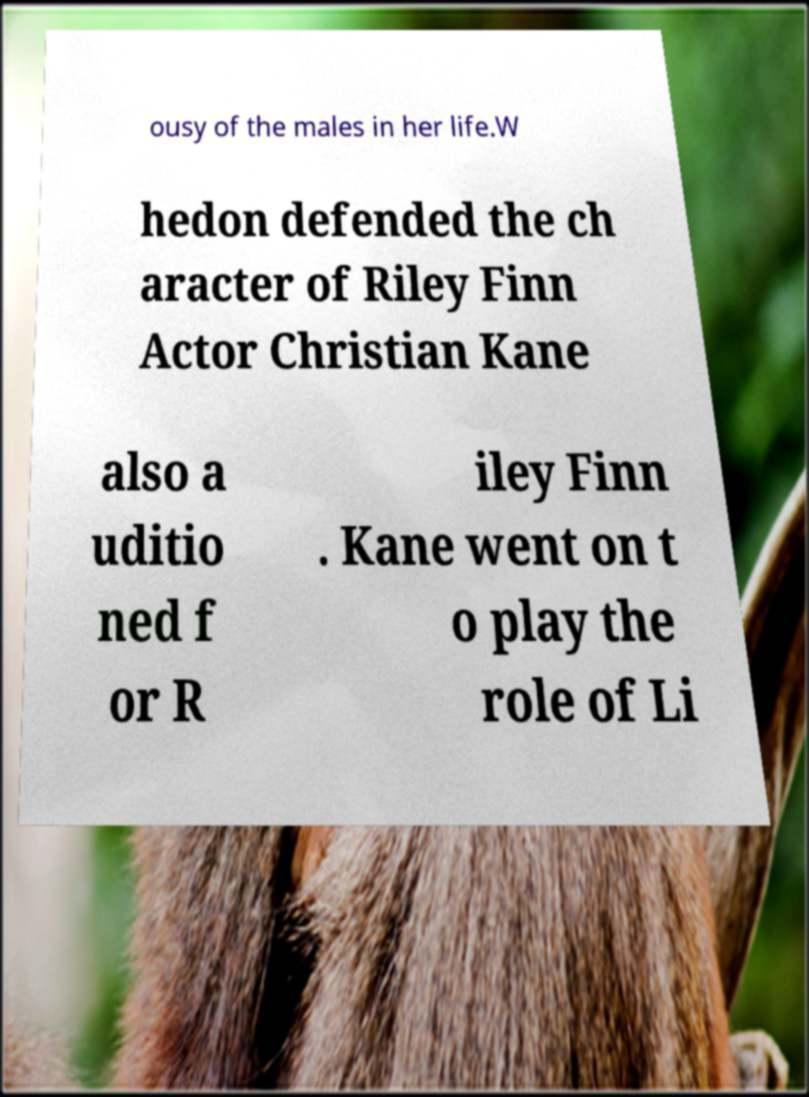Can you read and provide the text displayed in the image?This photo seems to have some interesting text. Can you extract and type it out for me? ousy of the males in her life.W hedon defended the ch aracter of Riley Finn Actor Christian Kane also a uditio ned f or R iley Finn . Kane went on t o play the role of Li 